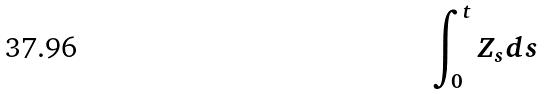<formula> <loc_0><loc_0><loc_500><loc_500>\int _ { 0 } ^ { t } Z _ { s } d s</formula> 